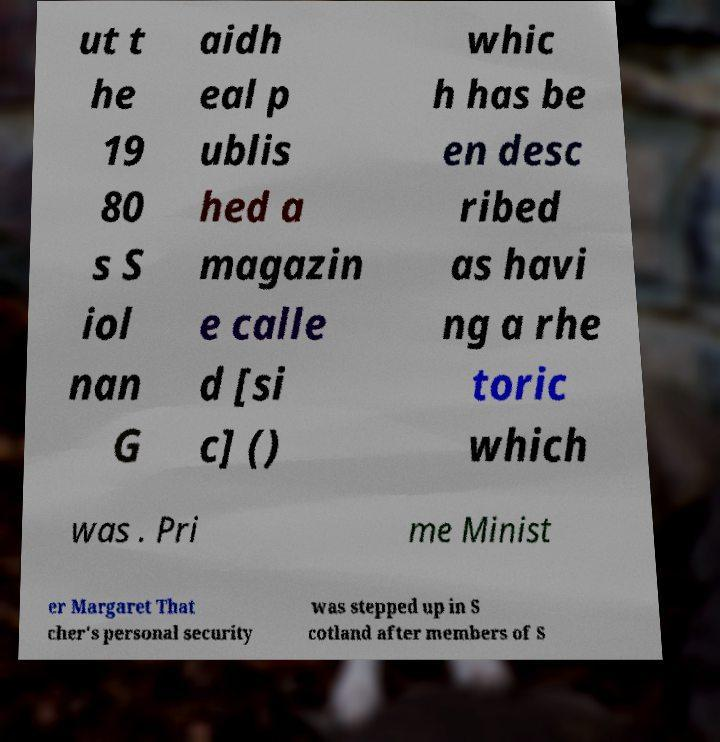Could you assist in decoding the text presented in this image and type it out clearly? ut t he 19 80 s S iol nan G aidh eal p ublis hed a magazin e calle d [si c] () whic h has be en desc ribed as havi ng a rhe toric which was . Pri me Minist er Margaret That cher's personal security was stepped up in S cotland after members of S 